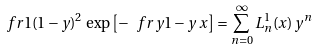<formula> <loc_0><loc_0><loc_500><loc_500>\ f r { 1 } { ( 1 - y ) ^ { 2 } } \, \exp \left [ - \ f r { y } { 1 - y } \, x \right ] = \sum _ { n = 0 } ^ { \infty } L _ { n } ^ { 1 } ( x ) \, y ^ { n }</formula> 